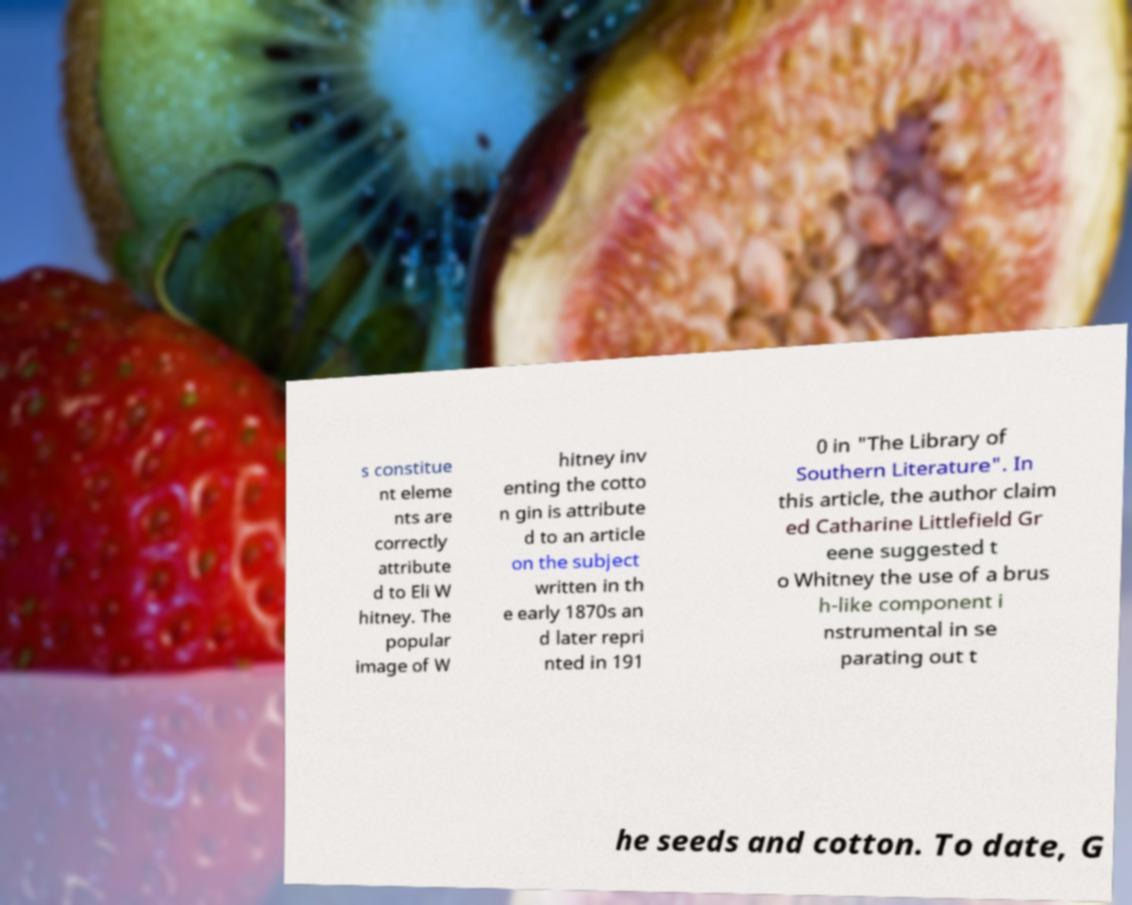Can you read and provide the text displayed in the image?This photo seems to have some interesting text. Can you extract and type it out for me? s constitue nt eleme nts are correctly attribute d to Eli W hitney. The popular image of W hitney inv enting the cotto n gin is attribute d to an article on the subject written in th e early 1870s an d later repri nted in 191 0 in "The Library of Southern Literature". In this article, the author claim ed Catharine Littlefield Gr eene suggested t o Whitney the use of a brus h-like component i nstrumental in se parating out t he seeds and cotton. To date, G 